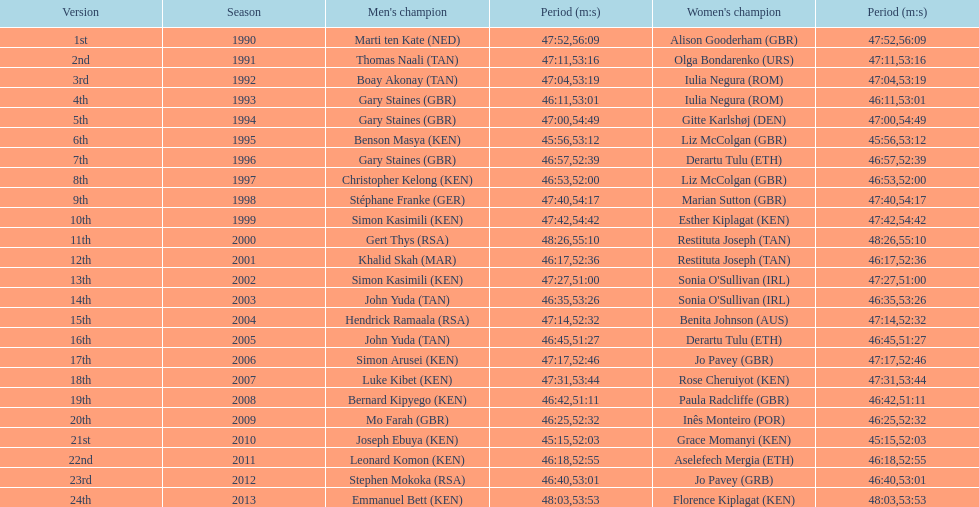What is the name of the first women's winner? Alison Gooderham. 